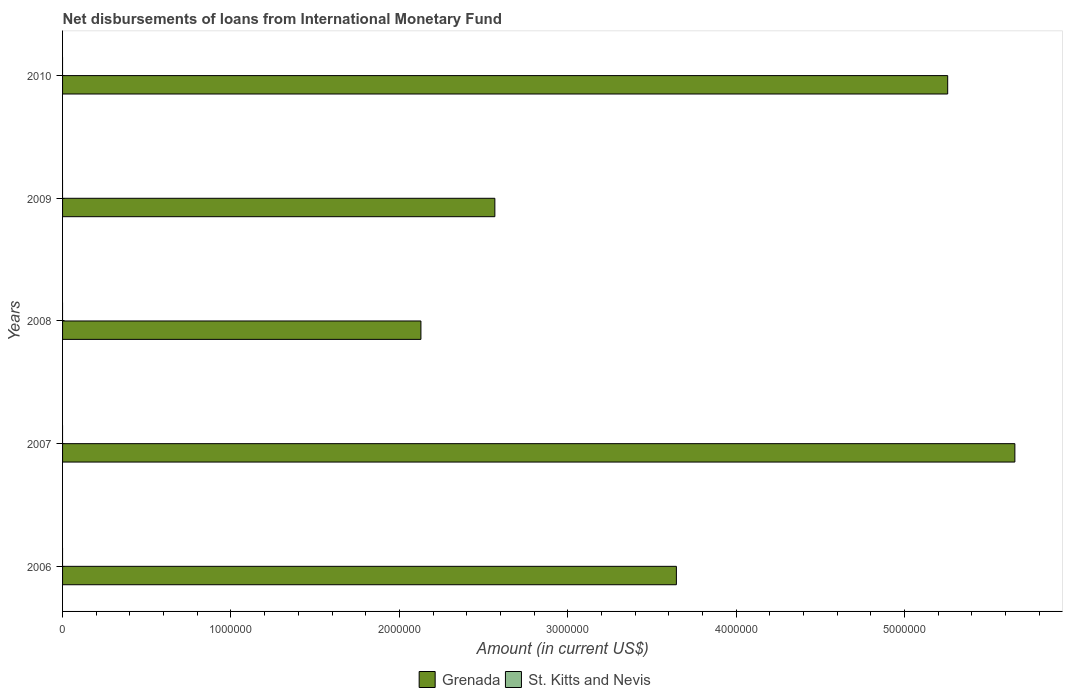How many different coloured bars are there?
Your answer should be very brief. 1. How many bars are there on the 3rd tick from the top?
Your answer should be very brief. 1. Across all years, what is the maximum amount of loans disbursed in Grenada?
Offer a terse response. 5.66e+06. In which year was the amount of loans disbursed in Grenada maximum?
Provide a succinct answer. 2007. What is the total amount of loans disbursed in Grenada in the graph?
Your answer should be very brief. 1.93e+07. What is the difference between the amount of loans disbursed in Grenada in 2008 and that in 2009?
Offer a very short reply. -4.39e+05. What is the difference between the amount of loans disbursed in St. Kitts and Nevis in 2010 and the amount of loans disbursed in Grenada in 2007?
Offer a very short reply. -5.66e+06. What is the average amount of loans disbursed in St. Kitts and Nevis per year?
Ensure brevity in your answer.  0. What is the ratio of the amount of loans disbursed in Grenada in 2007 to that in 2009?
Keep it short and to the point. 2.2. Is the amount of loans disbursed in Grenada in 2008 less than that in 2009?
Provide a succinct answer. Yes. What is the difference between the highest and the second highest amount of loans disbursed in Grenada?
Ensure brevity in your answer.  3.99e+05. What is the difference between the highest and the lowest amount of loans disbursed in Grenada?
Give a very brief answer. 3.53e+06. How many bars are there?
Your answer should be very brief. 5. How many years are there in the graph?
Give a very brief answer. 5. What is the difference between two consecutive major ticks on the X-axis?
Ensure brevity in your answer.  1.00e+06. Are the values on the major ticks of X-axis written in scientific E-notation?
Make the answer very short. No. Where does the legend appear in the graph?
Your answer should be very brief. Bottom center. What is the title of the graph?
Your answer should be very brief. Net disbursements of loans from International Monetary Fund. What is the label or title of the Y-axis?
Make the answer very short. Years. What is the Amount (in current US$) of Grenada in 2006?
Your response must be concise. 3.64e+06. What is the Amount (in current US$) in St. Kitts and Nevis in 2006?
Offer a terse response. 0. What is the Amount (in current US$) of Grenada in 2007?
Provide a short and direct response. 5.66e+06. What is the Amount (in current US$) in Grenada in 2008?
Ensure brevity in your answer.  2.13e+06. What is the Amount (in current US$) in St. Kitts and Nevis in 2008?
Keep it short and to the point. 0. What is the Amount (in current US$) in Grenada in 2009?
Your response must be concise. 2.57e+06. What is the Amount (in current US$) in Grenada in 2010?
Provide a succinct answer. 5.26e+06. What is the Amount (in current US$) in St. Kitts and Nevis in 2010?
Provide a short and direct response. 0. Across all years, what is the maximum Amount (in current US$) in Grenada?
Give a very brief answer. 5.66e+06. Across all years, what is the minimum Amount (in current US$) of Grenada?
Offer a very short reply. 2.13e+06. What is the total Amount (in current US$) in Grenada in the graph?
Your answer should be compact. 1.93e+07. What is the total Amount (in current US$) in St. Kitts and Nevis in the graph?
Keep it short and to the point. 0. What is the difference between the Amount (in current US$) in Grenada in 2006 and that in 2007?
Your response must be concise. -2.01e+06. What is the difference between the Amount (in current US$) in Grenada in 2006 and that in 2008?
Keep it short and to the point. 1.52e+06. What is the difference between the Amount (in current US$) in Grenada in 2006 and that in 2009?
Give a very brief answer. 1.08e+06. What is the difference between the Amount (in current US$) in Grenada in 2006 and that in 2010?
Keep it short and to the point. -1.61e+06. What is the difference between the Amount (in current US$) in Grenada in 2007 and that in 2008?
Provide a short and direct response. 3.53e+06. What is the difference between the Amount (in current US$) of Grenada in 2007 and that in 2009?
Offer a very short reply. 3.09e+06. What is the difference between the Amount (in current US$) of Grenada in 2007 and that in 2010?
Your answer should be compact. 3.99e+05. What is the difference between the Amount (in current US$) in Grenada in 2008 and that in 2009?
Ensure brevity in your answer.  -4.39e+05. What is the difference between the Amount (in current US$) of Grenada in 2008 and that in 2010?
Provide a succinct answer. -3.13e+06. What is the difference between the Amount (in current US$) of Grenada in 2009 and that in 2010?
Your response must be concise. -2.69e+06. What is the average Amount (in current US$) in Grenada per year?
Keep it short and to the point. 3.85e+06. What is the average Amount (in current US$) in St. Kitts and Nevis per year?
Offer a terse response. 0. What is the ratio of the Amount (in current US$) in Grenada in 2006 to that in 2007?
Keep it short and to the point. 0.64. What is the ratio of the Amount (in current US$) of Grenada in 2006 to that in 2008?
Give a very brief answer. 1.71. What is the ratio of the Amount (in current US$) of Grenada in 2006 to that in 2009?
Offer a terse response. 1.42. What is the ratio of the Amount (in current US$) in Grenada in 2006 to that in 2010?
Ensure brevity in your answer.  0.69. What is the ratio of the Amount (in current US$) in Grenada in 2007 to that in 2008?
Your response must be concise. 2.66. What is the ratio of the Amount (in current US$) in Grenada in 2007 to that in 2009?
Your answer should be very brief. 2.2. What is the ratio of the Amount (in current US$) of Grenada in 2007 to that in 2010?
Provide a succinct answer. 1.08. What is the ratio of the Amount (in current US$) of Grenada in 2008 to that in 2009?
Your answer should be very brief. 0.83. What is the ratio of the Amount (in current US$) of Grenada in 2008 to that in 2010?
Your response must be concise. 0.4. What is the ratio of the Amount (in current US$) of Grenada in 2009 to that in 2010?
Your answer should be compact. 0.49. What is the difference between the highest and the second highest Amount (in current US$) of Grenada?
Provide a short and direct response. 3.99e+05. What is the difference between the highest and the lowest Amount (in current US$) in Grenada?
Your answer should be compact. 3.53e+06. 